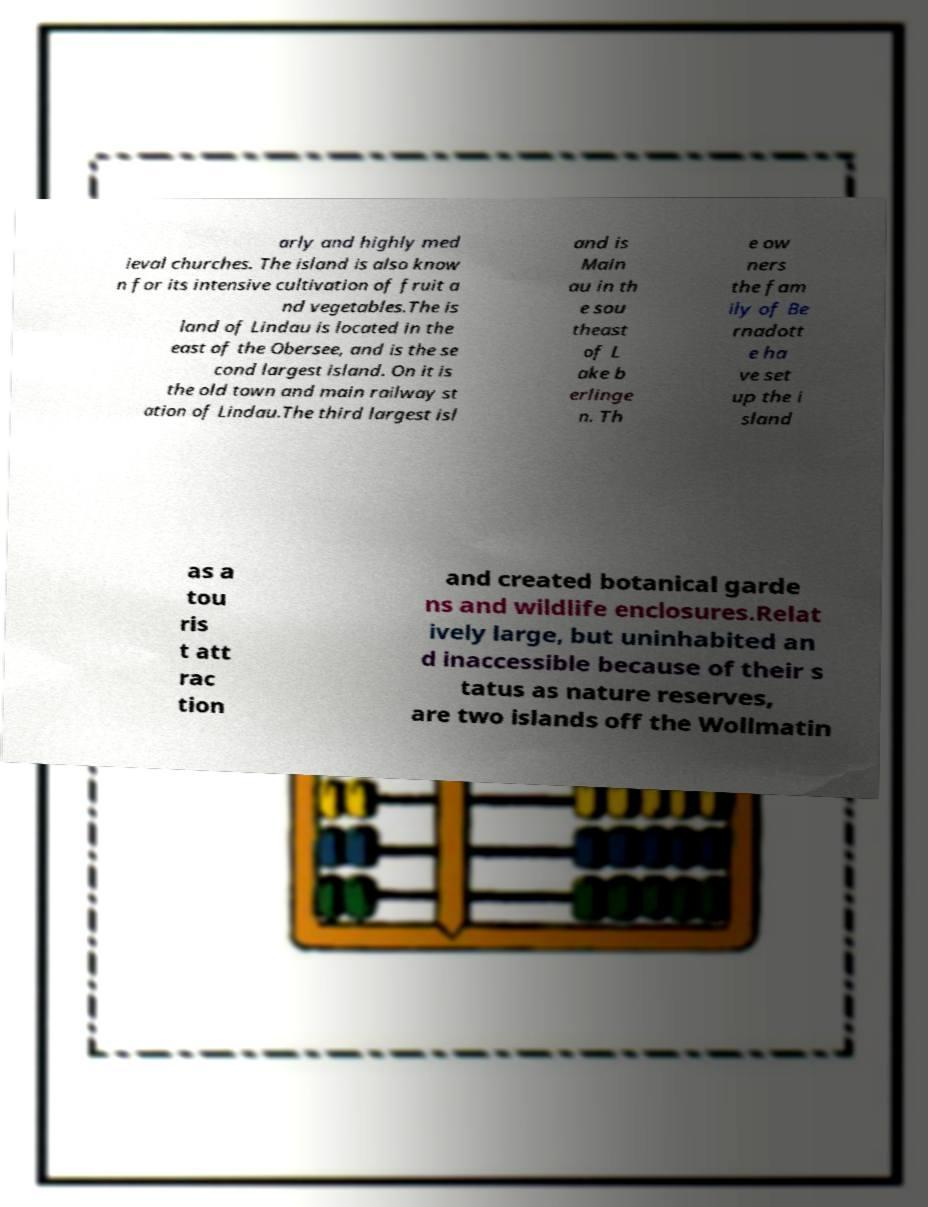Could you extract and type out the text from this image? arly and highly med ieval churches. The island is also know n for its intensive cultivation of fruit a nd vegetables.The is land of Lindau is located in the east of the Obersee, and is the se cond largest island. On it is the old town and main railway st ation of Lindau.The third largest isl and is Main au in th e sou theast of L ake b erlinge n. Th e ow ners the fam ily of Be rnadott e ha ve set up the i sland as a tou ris t att rac tion and created botanical garde ns and wildlife enclosures.Relat ively large, but uninhabited an d inaccessible because of their s tatus as nature reserves, are two islands off the Wollmatin 